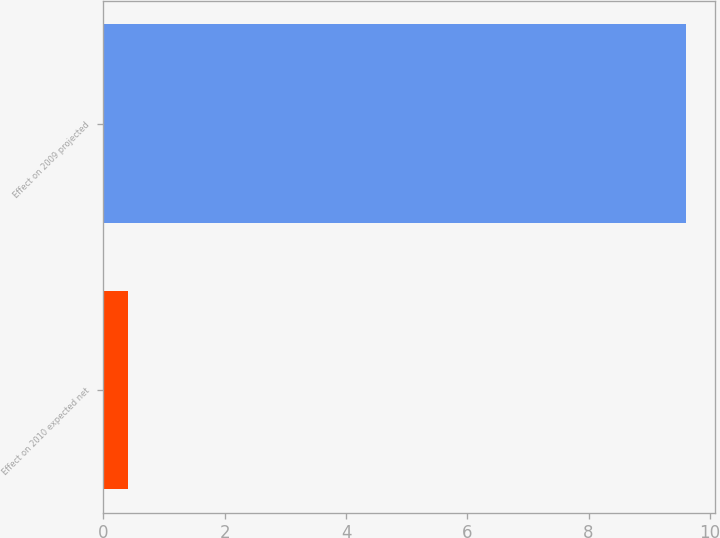<chart> <loc_0><loc_0><loc_500><loc_500><bar_chart><fcel>Effect on 2010 expected net<fcel>Effect on 2009 projected<nl><fcel>0.4<fcel>9.6<nl></chart> 